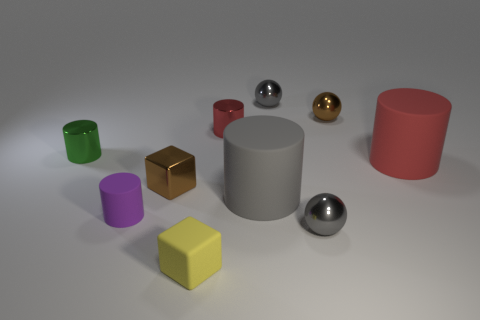The ball that is the same color as the tiny metallic cube is what size?
Provide a succinct answer. Small. What number of tiny metal spheres are the same color as the metal cube?
Your response must be concise. 1. Does the tiny brown shiny object that is in front of the big red matte thing have the same shape as the small purple matte thing?
Offer a terse response. No. How many purple things are matte blocks or rubber balls?
Ensure brevity in your answer.  0. Are there an equal number of small yellow rubber cubes that are behind the big red cylinder and small green metal things that are in front of the purple thing?
Offer a terse response. Yes. There is a large object in front of the red cylinder in front of the tiny red shiny object behind the green thing; what is its color?
Provide a short and direct response. Gray. Are there any other things that have the same color as the tiny rubber cylinder?
Make the answer very short. No. What shape is the tiny object that is the same color as the small metal cube?
Make the answer very short. Sphere. How big is the metallic cylinder that is to the right of the small yellow block?
Offer a very short reply. Small. There is a yellow rubber thing that is the same size as the purple rubber thing; what is its shape?
Provide a short and direct response. Cube. 